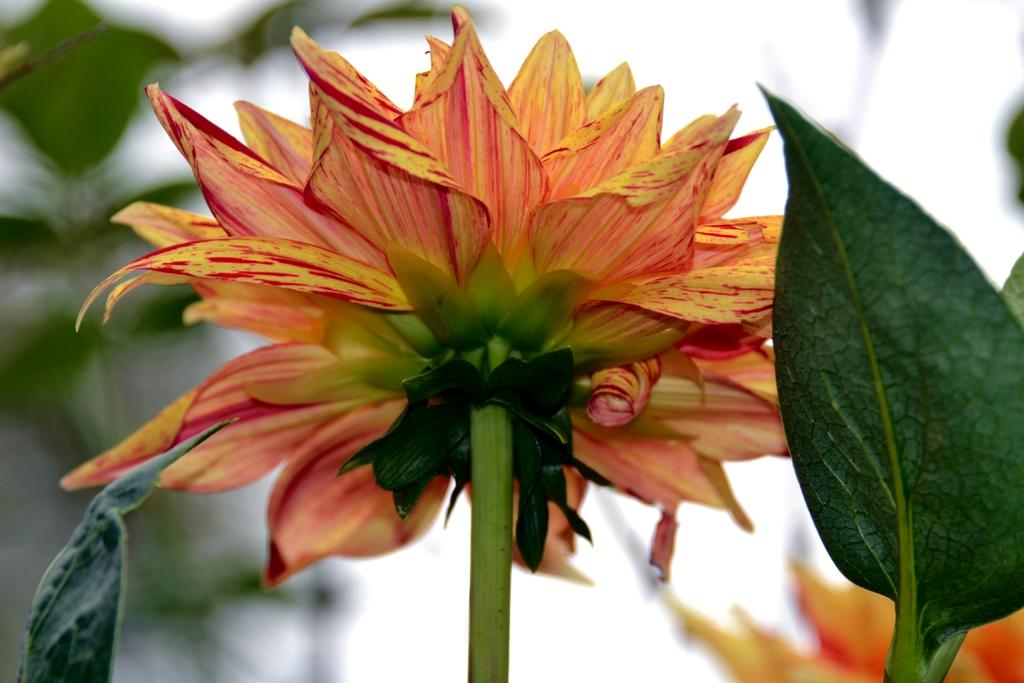What is the main subject of the image? There is a flower in the image. What color is the flower? The flower is orange in color. Are there any other elements near the flower? Yes, there is a leaf to the right of the flower. How would you describe the background of the image? The background of the image is blurred. How many tickets can be seen in the image? There are no tickets present in the image; it features a flower and a leaf. What type of egg is visible in the image? There is no egg present in the image. 